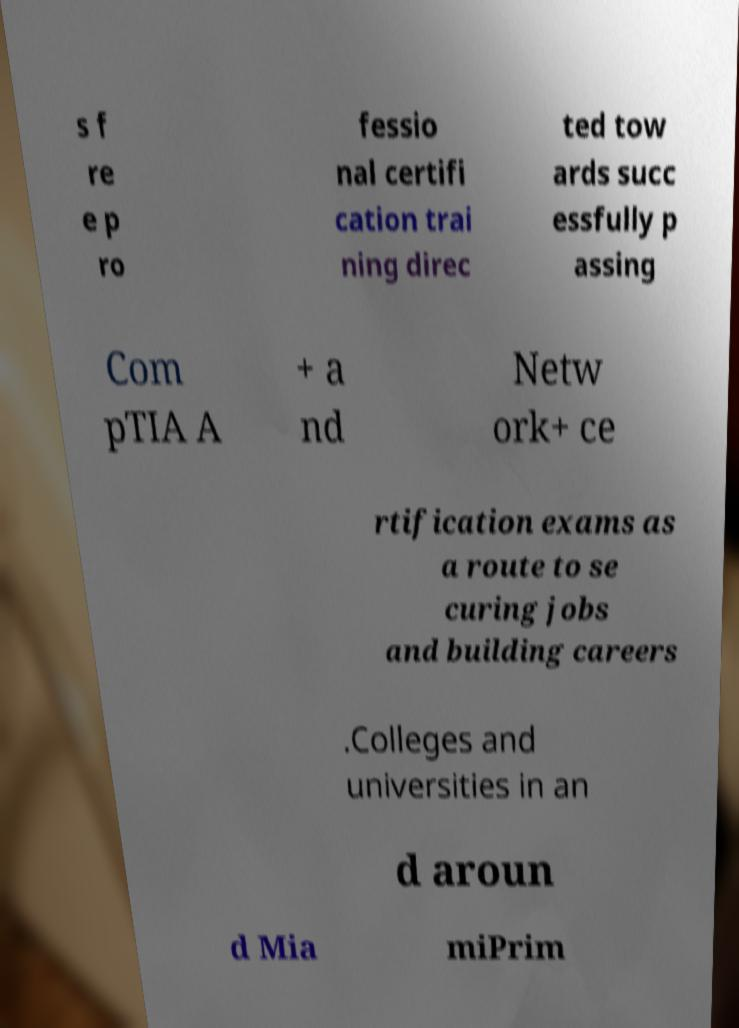Could you assist in decoding the text presented in this image and type it out clearly? s f re e p ro fessio nal certifi cation trai ning direc ted tow ards succ essfully p assing Com pTIA A + a nd Netw ork+ ce rtification exams as a route to se curing jobs and building careers .Colleges and universities in an d aroun d Mia miPrim 